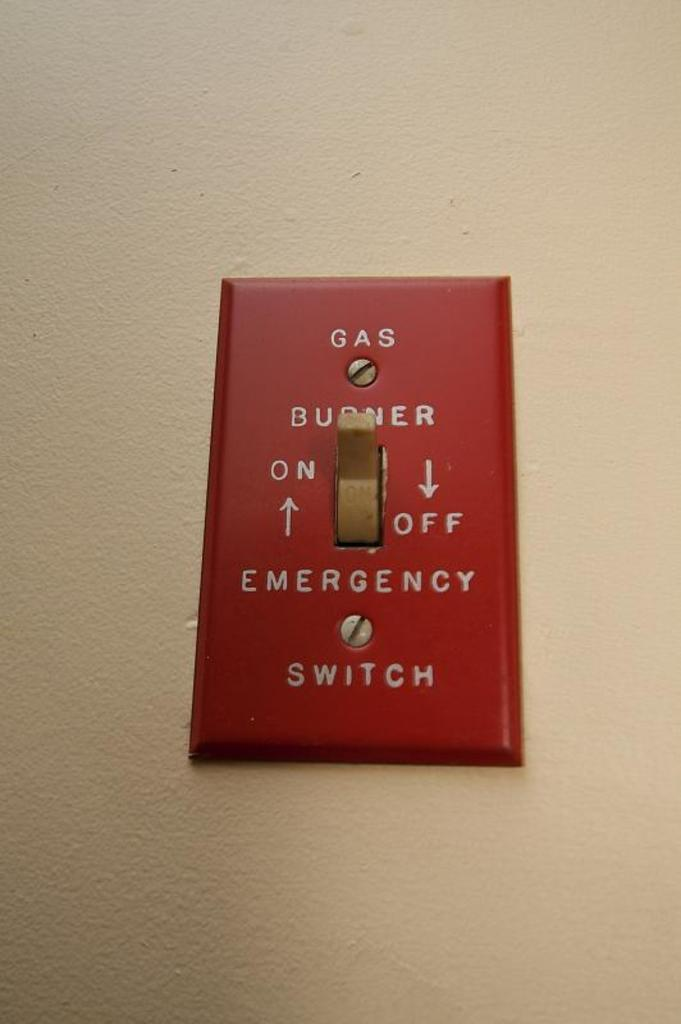What type of device is located on the wall in the image? There is an emergency switch on the wall in the image. What is the stomach of the person in the image feeling? There is no person present in the image, so it is not possible to determine how their stomach might be feeling. 